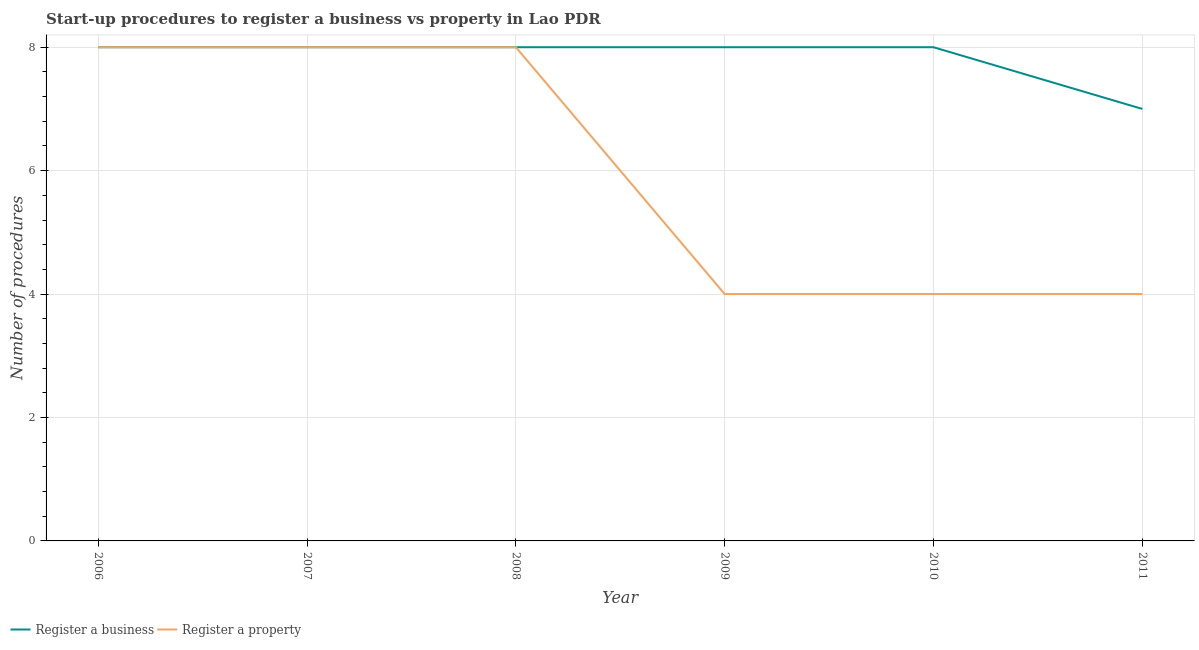How many different coloured lines are there?
Your answer should be compact. 2. What is the number of procedures to register a business in 2010?
Provide a short and direct response. 8. Across all years, what is the maximum number of procedures to register a property?
Provide a short and direct response. 8. Across all years, what is the minimum number of procedures to register a business?
Give a very brief answer. 7. In which year was the number of procedures to register a business maximum?
Your response must be concise. 2006. In which year was the number of procedures to register a property minimum?
Keep it short and to the point. 2009. What is the total number of procedures to register a property in the graph?
Your answer should be compact. 36. What is the difference between the number of procedures to register a business in 2011 and the number of procedures to register a property in 2007?
Offer a very short reply. -1. What is the average number of procedures to register a property per year?
Provide a succinct answer. 6. In the year 2007, what is the difference between the number of procedures to register a property and number of procedures to register a business?
Provide a short and direct response. 0. In how many years, is the number of procedures to register a property greater than 0.4?
Make the answer very short. 6. What is the ratio of the number of procedures to register a property in 2007 to that in 2011?
Offer a very short reply. 2. Is the difference between the number of procedures to register a business in 2008 and 2011 greater than the difference between the number of procedures to register a property in 2008 and 2011?
Ensure brevity in your answer.  No. What is the difference between the highest and the second highest number of procedures to register a property?
Offer a terse response. 0. What is the difference between the highest and the lowest number of procedures to register a business?
Make the answer very short. 1. In how many years, is the number of procedures to register a business greater than the average number of procedures to register a business taken over all years?
Make the answer very short. 5. Does the number of procedures to register a business monotonically increase over the years?
Keep it short and to the point. No. Is the number of procedures to register a business strictly greater than the number of procedures to register a property over the years?
Your answer should be very brief. No. How many lines are there?
Your answer should be very brief. 2. How many years are there in the graph?
Offer a very short reply. 6. Are the values on the major ticks of Y-axis written in scientific E-notation?
Your response must be concise. No. Where does the legend appear in the graph?
Your response must be concise. Bottom left. How many legend labels are there?
Your response must be concise. 2. How are the legend labels stacked?
Provide a succinct answer. Horizontal. What is the title of the graph?
Keep it short and to the point. Start-up procedures to register a business vs property in Lao PDR. Does "Male population" appear as one of the legend labels in the graph?
Your answer should be compact. No. What is the label or title of the X-axis?
Ensure brevity in your answer.  Year. What is the label or title of the Y-axis?
Your response must be concise. Number of procedures. What is the Number of procedures of Register a business in 2006?
Give a very brief answer. 8. What is the Number of procedures of Register a business in 2007?
Keep it short and to the point. 8. What is the Number of procedures in Register a property in 2009?
Your answer should be compact. 4. What is the Number of procedures of Register a business in 2011?
Offer a terse response. 7. What is the total Number of procedures in Register a business in the graph?
Provide a succinct answer. 47. What is the difference between the Number of procedures in Register a business in 2006 and that in 2007?
Ensure brevity in your answer.  0. What is the difference between the Number of procedures in Register a property in 2006 and that in 2007?
Offer a very short reply. 0. What is the difference between the Number of procedures in Register a business in 2006 and that in 2009?
Provide a short and direct response. 0. What is the difference between the Number of procedures in Register a property in 2006 and that in 2010?
Make the answer very short. 4. What is the difference between the Number of procedures in Register a property in 2006 and that in 2011?
Provide a short and direct response. 4. What is the difference between the Number of procedures in Register a property in 2007 and that in 2009?
Offer a very short reply. 4. What is the difference between the Number of procedures of Register a business in 2007 and that in 2011?
Offer a terse response. 1. What is the difference between the Number of procedures of Register a property in 2007 and that in 2011?
Offer a very short reply. 4. What is the difference between the Number of procedures of Register a business in 2008 and that in 2010?
Offer a very short reply. 0. What is the difference between the Number of procedures in Register a property in 2008 and that in 2010?
Make the answer very short. 4. What is the difference between the Number of procedures of Register a business in 2008 and that in 2011?
Your answer should be very brief. 1. What is the difference between the Number of procedures in Register a property in 2009 and that in 2010?
Your answer should be compact. 0. What is the difference between the Number of procedures in Register a business in 2009 and that in 2011?
Provide a succinct answer. 1. What is the difference between the Number of procedures in Register a property in 2010 and that in 2011?
Ensure brevity in your answer.  0. What is the difference between the Number of procedures of Register a business in 2006 and the Number of procedures of Register a property in 2008?
Offer a very short reply. 0. What is the difference between the Number of procedures in Register a business in 2006 and the Number of procedures in Register a property in 2010?
Your answer should be compact. 4. What is the difference between the Number of procedures of Register a business in 2006 and the Number of procedures of Register a property in 2011?
Your answer should be very brief. 4. What is the difference between the Number of procedures in Register a business in 2007 and the Number of procedures in Register a property in 2008?
Provide a succinct answer. 0. What is the difference between the Number of procedures of Register a business in 2007 and the Number of procedures of Register a property in 2010?
Provide a short and direct response. 4. What is the difference between the Number of procedures in Register a business in 2007 and the Number of procedures in Register a property in 2011?
Offer a very short reply. 4. What is the difference between the Number of procedures of Register a business in 2008 and the Number of procedures of Register a property in 2009?
Provide a succinct answer. 4. What is the difference between the Number of procedures of Register a business in 2009 and the Number of procedures of Register a property in 2010?
Give a very brief answer. 4. What is the difference between the Number of procedures of Register a business in 2009 and the Number of procedures of Register a property in 2011?
Your answer should be compact. 4. What is the difference between the Number of procedures of Register a business in 2010 and the Number of procedures of Register a property in 2011?
Give a very brief answer. 4. What is the average Number of procedures in Register a business per year?
Ensure brevity in your answer.  7.83. In the year 2007, what is the difference between the Number of procedures in Register a business and Number of procedures in Register a property?
Keep it short and to the point. 0. In the year 2008, what is the difference between the Number of procedures in Register a business and Number of procedures in Register a property?
Your answer should be very brief. 0. In the year 2009, what is the difference between the Number of procedures of Register a business and Number of procedures of Register a property?
Ensure brevity in your answer.  4. In the year 2011, what is the difference between the Number of procedures in Register a business and Number of procedures in Register a property?
Ensure brevity in your answer.  3. What is the ratio of the Number of procedures of Register a property in 2006 to that in 2007?
Ensure brevity in your answer.  1. What is the ratio of the Number of procedures of Register a business in 2006 to that in 2008?
Provide a succinct answer. 1. What is the ratio of the Number of procedures in Register a business in 2006 to that in 2009?
Make the answer very short. 1. What is the ratio of the Number of procedures of Register a property in 2006 to that in 2009?
Your answer should be compact. 2. What is the ratio of the Number of procedures of Register a business in 2006 to that in 2010?
Give a very brief answer. 1. What is the ratio of the Number of procedures in Register a business in 2006 to that in 2011?
Ensure brevity in your answer.  1.14. What is the ratio of the Number of procedures of Register a property in 2006 to that in 2011?
Make the answer very short. 2. What is the ratio of the Number of procedures of Register a business in 2007 to that in 2008?
Offer a terse response. 1. What is the ratio of the Number of procedures in Register a property in 2007 to that in 2009?
Ensure brevity in your answer.  2. What is the ratio of the Number of procedures of Register a business in 2007 to that in 2010?
Your response must be concise. 1. What is the ratio of the Number of procedures of Register a property in 2007 to that in 2010?
Make the answer very short. 2. What is the ratio of the Number of procedures in Register a business in 2007 to that in 2011?
Provide a short and direct response. 1.14. What is the ratio of the Number of procedures in Register a business in 2008 to that in 2009?
Provide a short and direct response. 1. What is the ratio of the Number of procedures of Register a property in 2008 to that in 2009?
Keep it short and to the point. 2. What is the ratio of the Number of procedures in Register a business in 2008 to that in 2011?
Provide a succinct answer. 1.14. What is the ratio of the Number of procedures in Register a property in 2008 to that in 2011?
Provide a short and direct response. 2. What is the ratio of the Number of procedures of Register a business in 2010 to that in 2011?
Offer a very short reply. 1.14. What is the ratio of the Number of procedures of Register a property in 2010 to that in 2011?
Offer a very short reply. 1. What is the difference between the highest and the second highest Number of procedures in Register a business?
Your response must be concise. 0. What is the difference between the highest and the second highest Number of procedures of Register a property?
Offer a terse response. 0. What is the difference between the highest and the lowest Number of procedures in Register a property?
Your answer should be very brief. 4. 